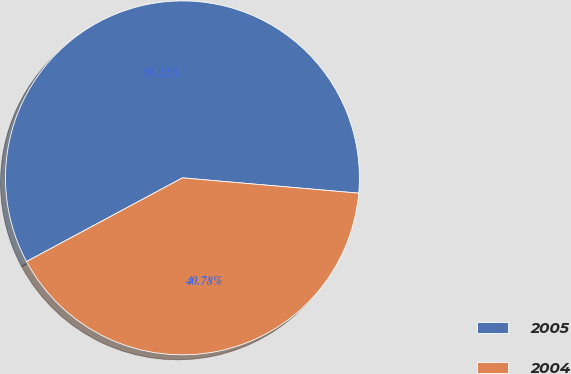Convert chart to OTSL. <chart><loc_0><loc_0><loc_500><loc_500><pie_chart><fcel>2005<fcel>2004<nl><fcel>59.22%<fcel>40.78%<nl></chart> 